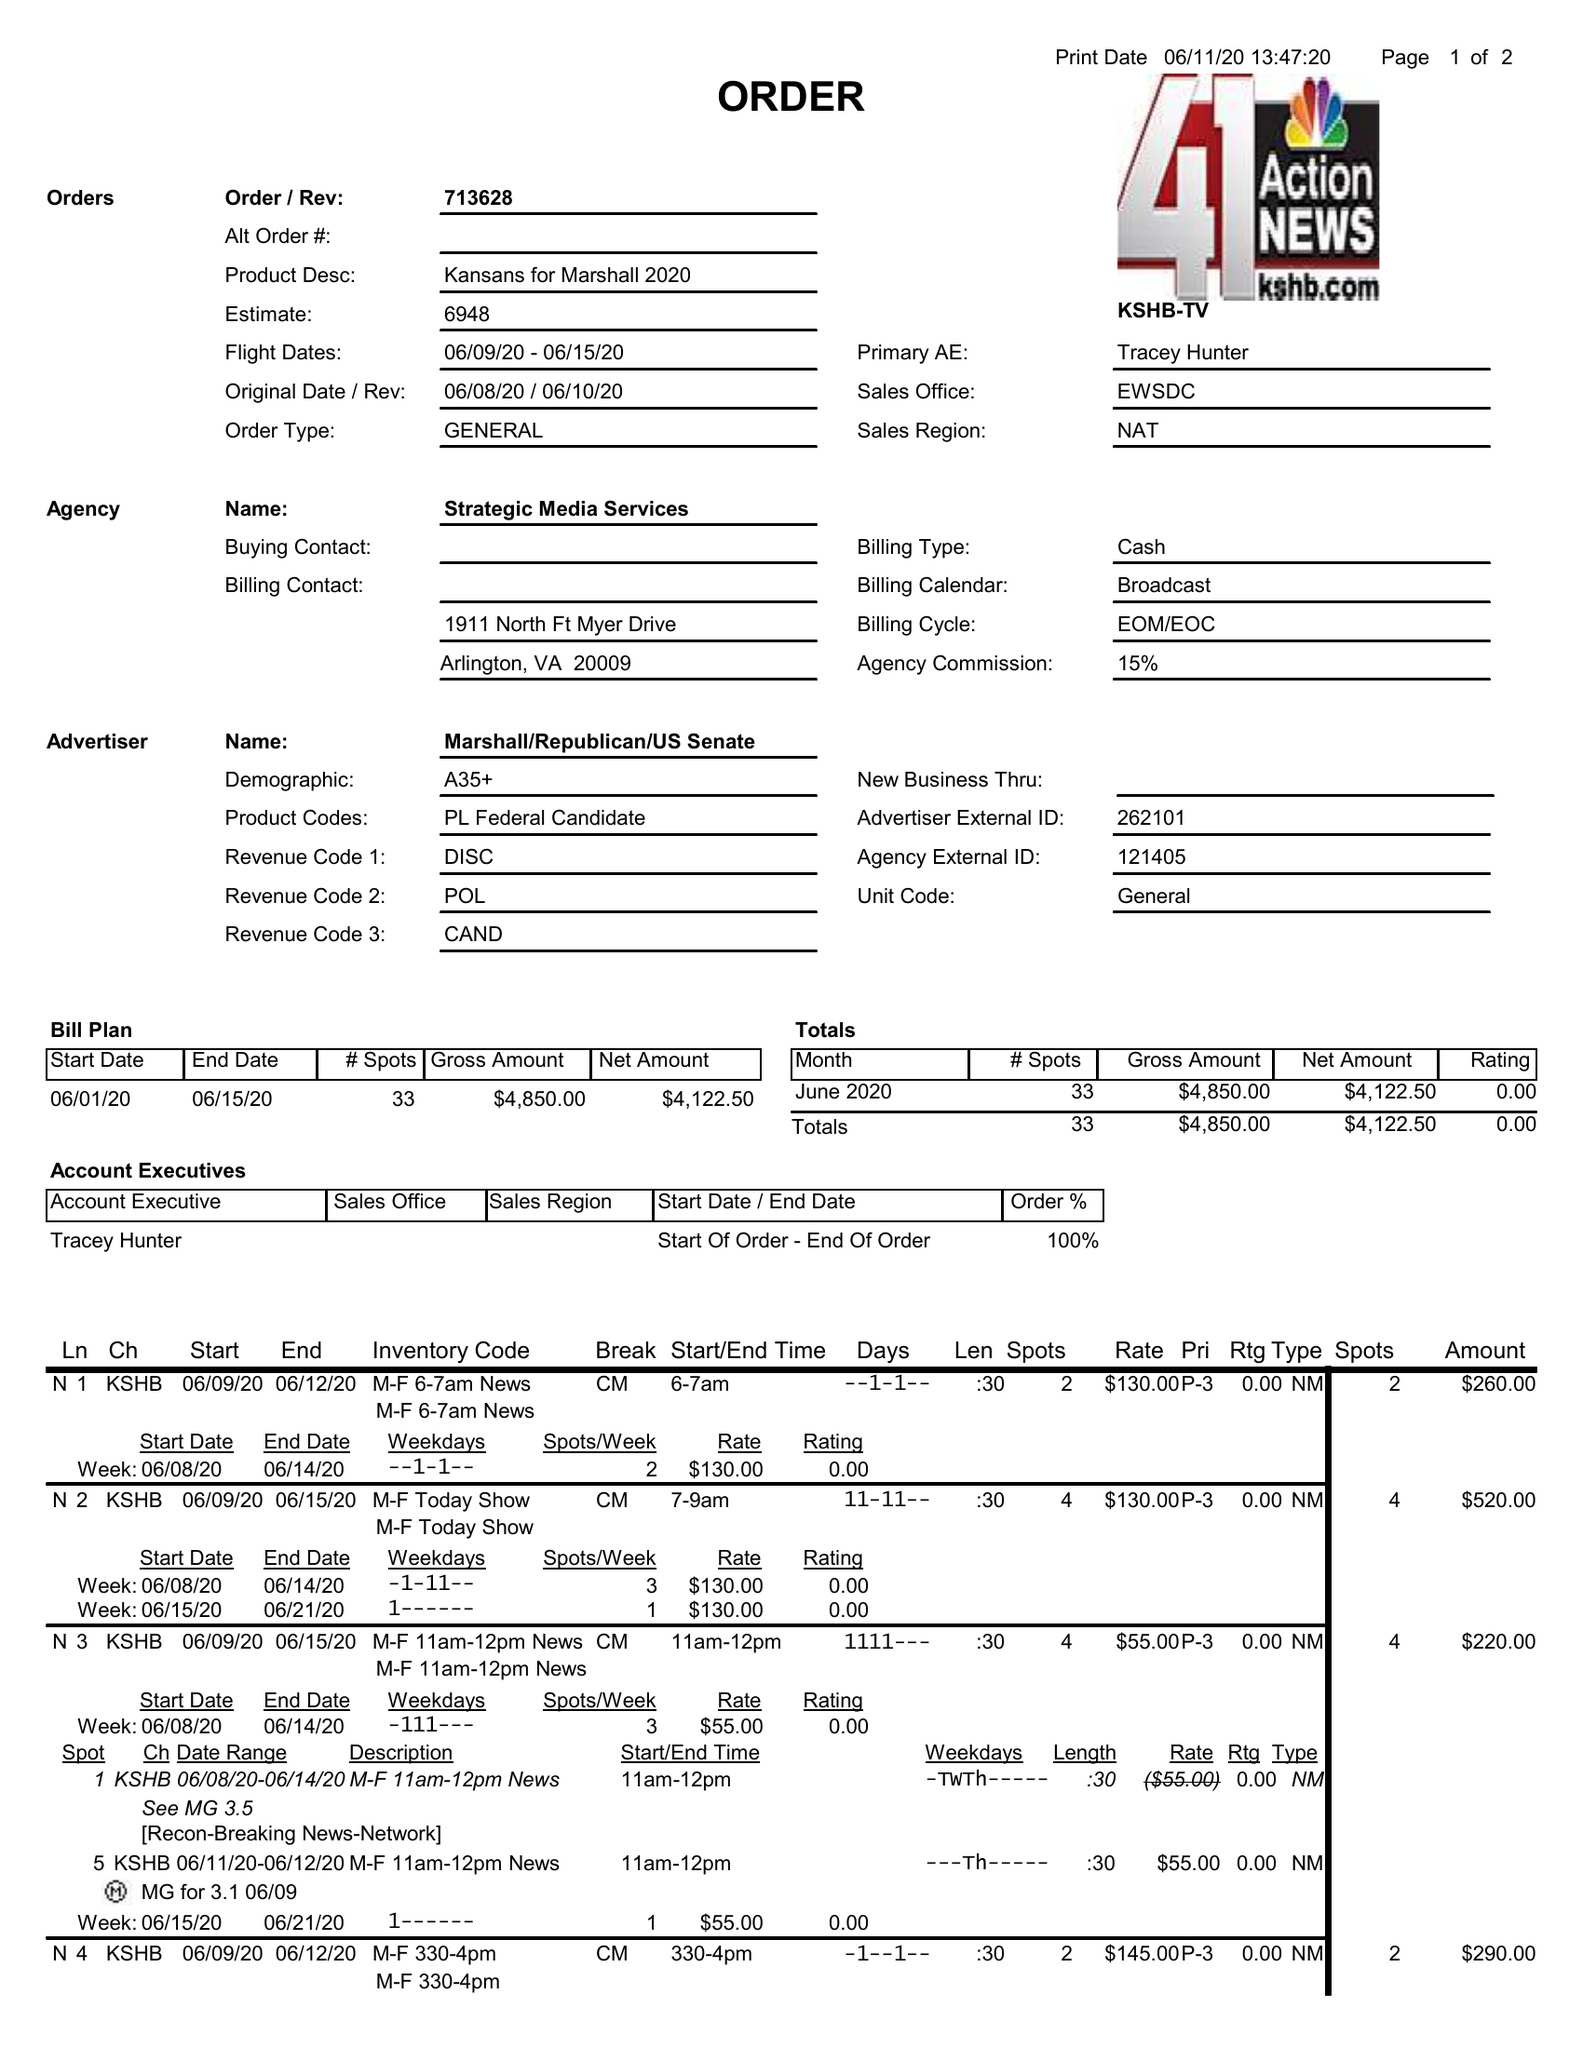What is the value for the advertiser?
Answer the question using a single word or phrase. MARSHALL/REPUBLICAN/USSENATE 